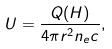Convert formula to latex. <formula><loc_0><loc_0><loc_500><loc_500>U = \frac { Q ( H ) } { 4 \pi r ^ { 2 } n _ { e } c } ,</formula> 